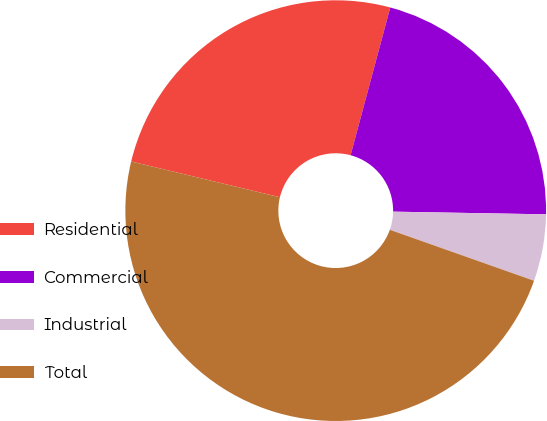Convert chart to OTSL. <chart><loc_0><loc_0><loc_500><loc_500><pie_chart><fcel>Residential<fcel>Commercial<fcel>Industrial<fcel>Total<nl><fcel>25.42%<fcel>21.1%<fcel>5.13%<fcel>48.34%<nl></chart> 